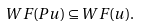<formula> <loc_0><loc_0><loc_500><loc_500>W F ( P u ) \subseteq W F ( u ) .</formula> 